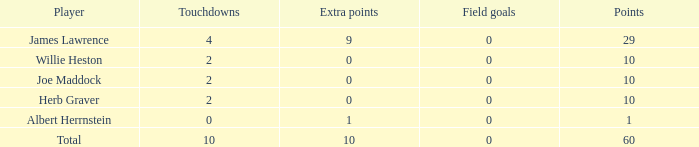For players with under 2 touchdowns and below 1 point, what is the greatest number of extra points they can have? None. 